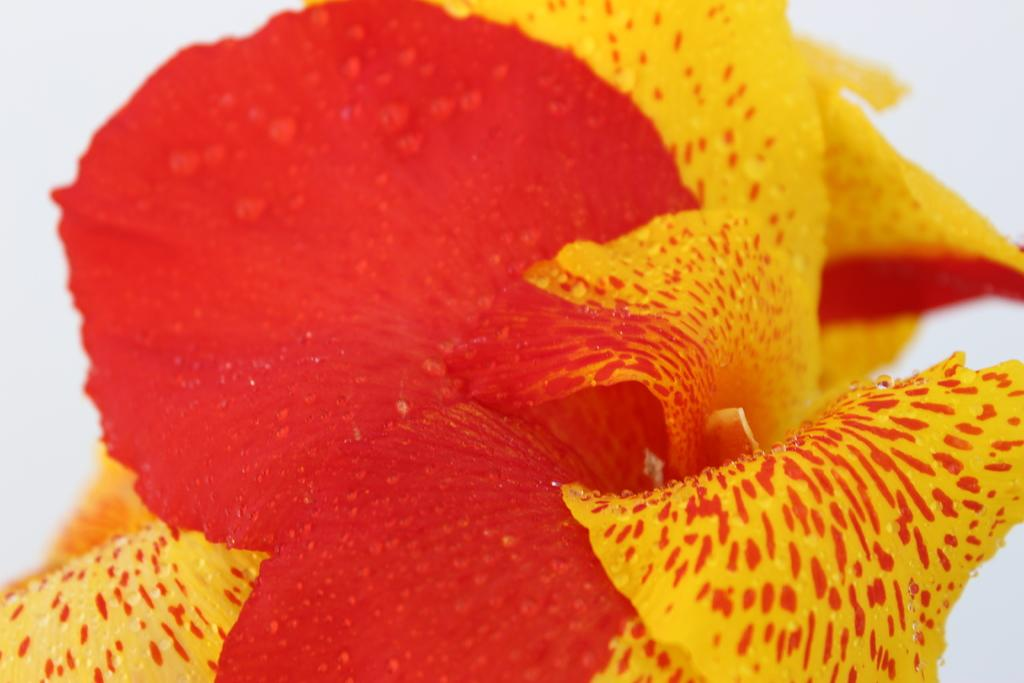What is the main subject of the image? There is a flower in the image. Can you describe the colors of the flower? The flower has red and yellow colors. What color is the background of the image? The background of the image is white. Is there a hook hanging from the flower in the image? No, there is no hook present in the image. 